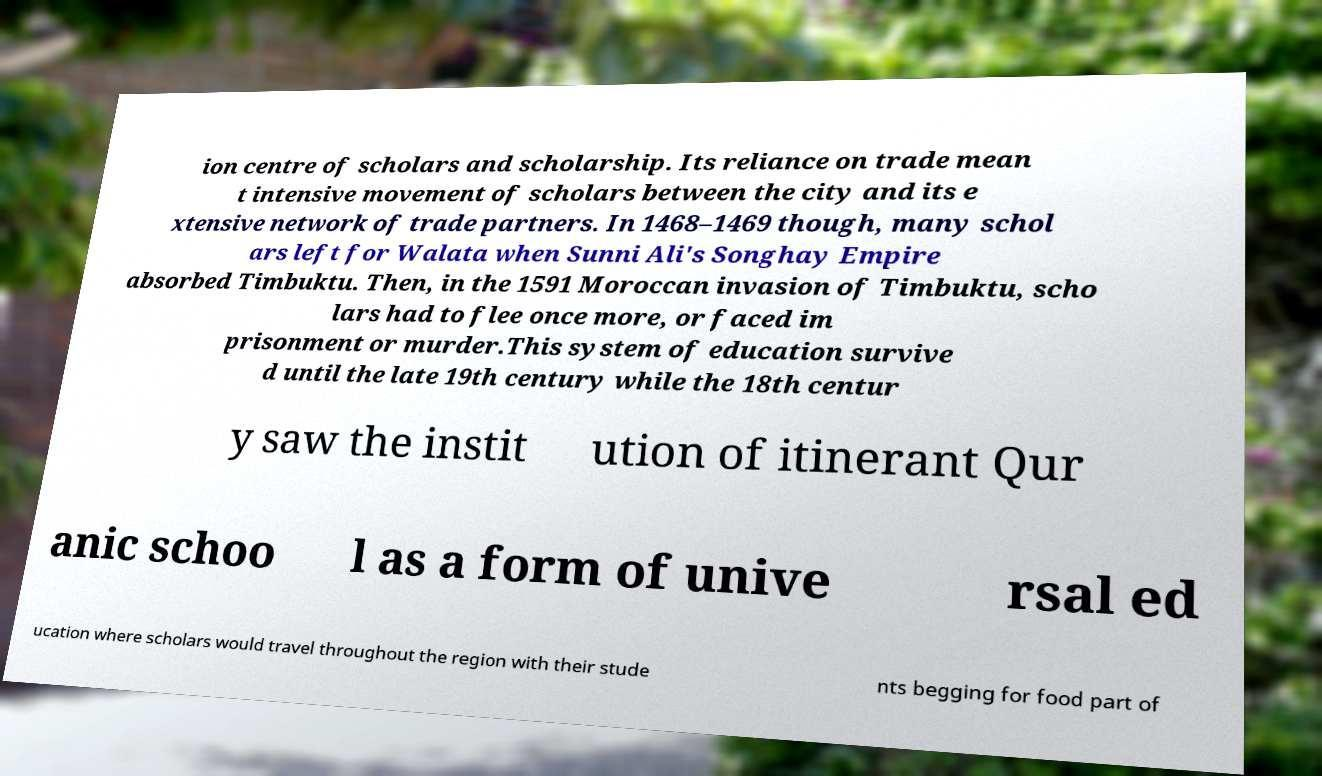Can you accurately transcribe the text from the provided image for me? ion centre of scholars and scholarship. Its reliance on trade mean t intensive movement of scholars between the city and its e xtensive network of trade partners. In 1468–1469 though, many schol ars left for Walata when Sunni Ali's Songhay Empire absorbed Timbuktu. Then, in the 1591 Moroccan invasion of Timbuktu, scho lars had to flee once more, or faced im prisonment or murder.This system of education survive d until the late 19th century while the 18th centur y saw the instit ution of itinerant Qur anic schoo l as a form of unive rsal ed ucation where scholars would travel throughout the region with their stude nts begging for food part of 